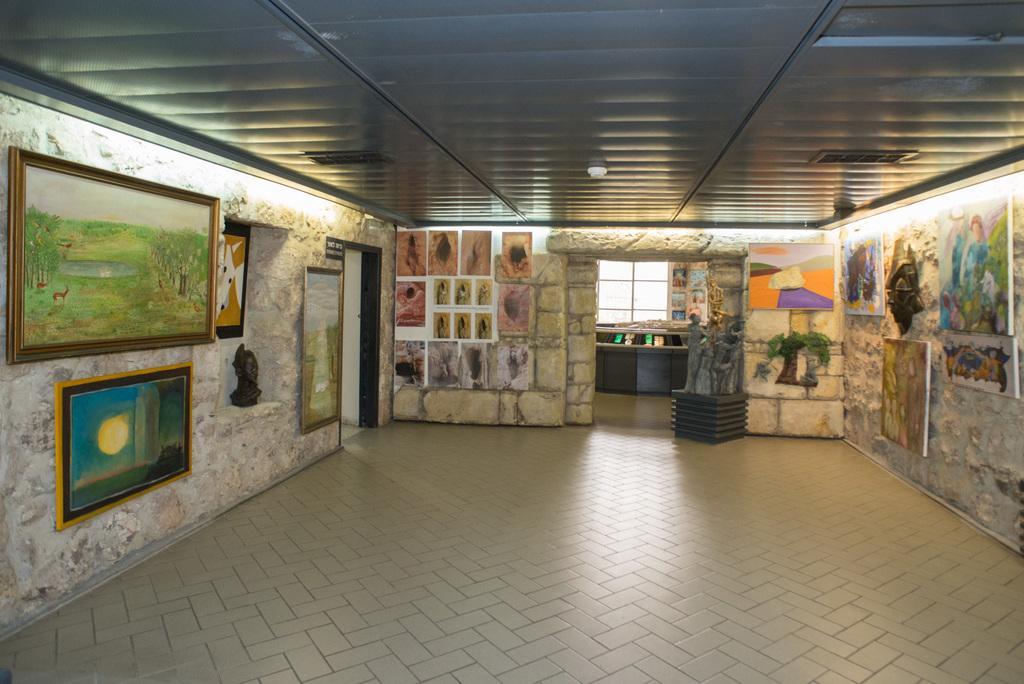Could you give a brief overview of what you see in this image? In this picture we can see the frames, boards on the walls. We can see the ceiling, objects and the floor. 